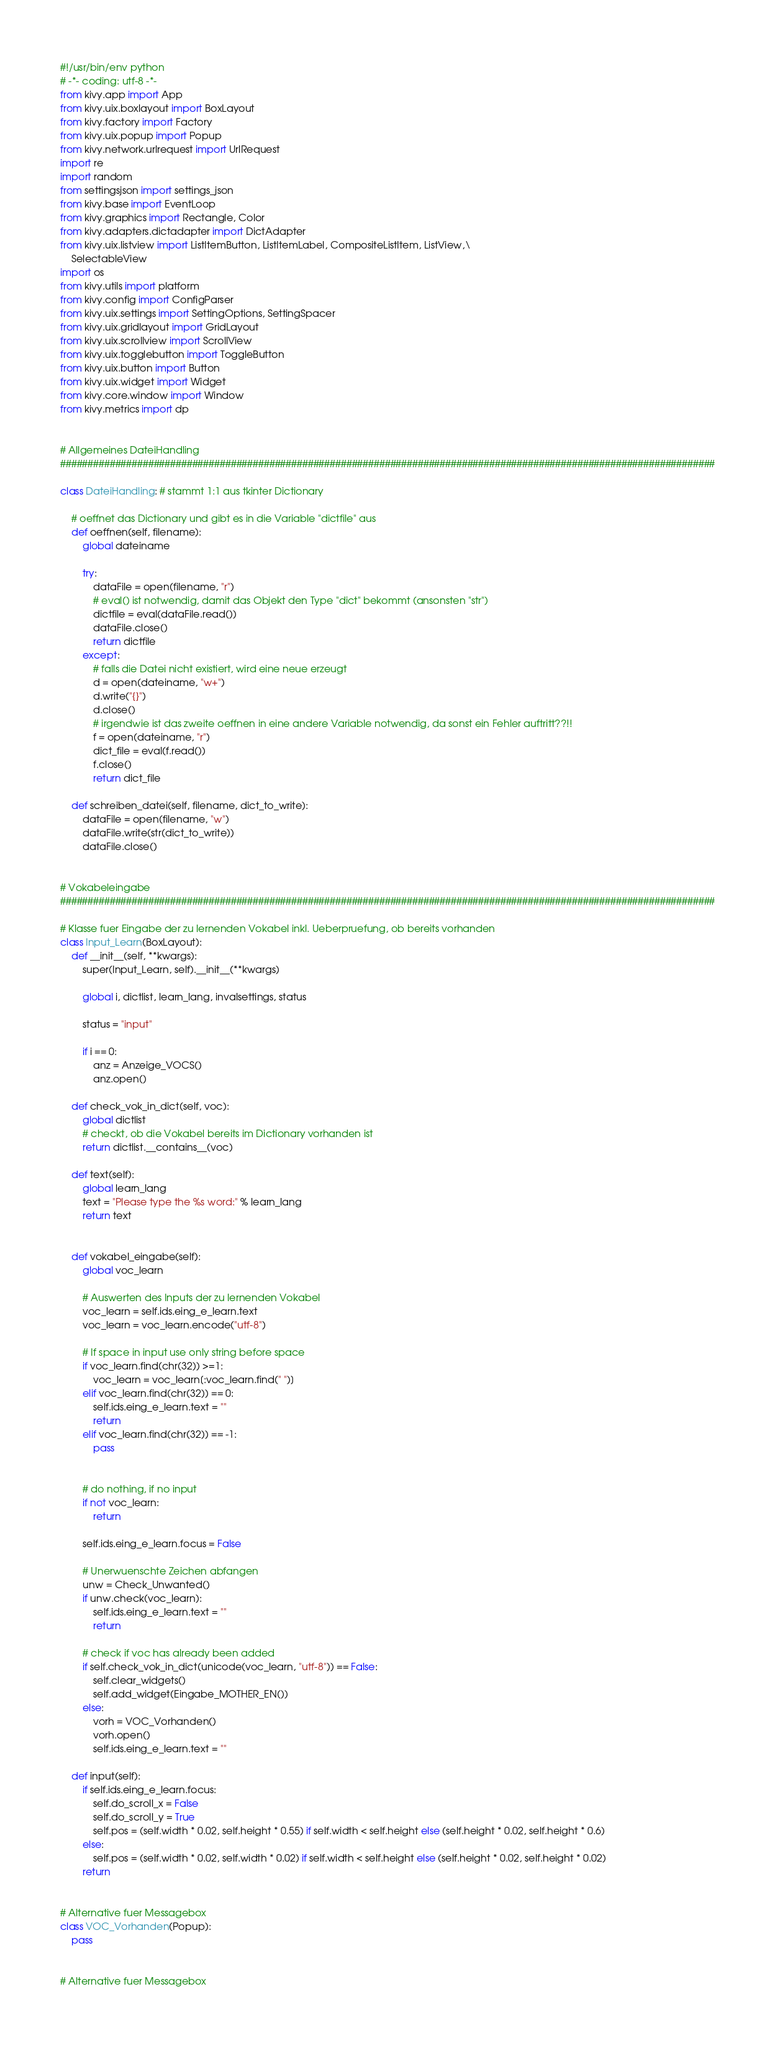Convert code to text. <code><loc_0><loc_0><loc_500><loc_500><_Python_>#!/usr/bin/env python
# -*- coding: utf-8 -*-
from kivy.app import App
from kivy.uix.boxlayout import BoxLayout
from kivy.factory import Factory
from kivy.uix.popup import Popup
from kivy.network.urlrequest import UrlRequest
import re
import random
from settingsjson import settings_json
from kivy.base import EventLoop
from kivy.graphics import Rectangle, Color
from kivy.adapters.dictadapter import DictAdapter
from kivy.uix.listview import ListItemButton, ListItemLabel, CompositeListItem, ListView,\
    SelectableView
import os
from kivy.utils import platform
from kivy.config import ConfigParser
from kivy.uix.settings import SettingOptions, SettingSpacer
from kivy.uix.gridlayout import GridLayout
from kivy.uix.scrollview import ScrollView
from kivy.uix.togglebutton import ToggleButton
from kivy.uix.button import Button
from kivy.uix.widget import Widget
from kivy.core.window import Window
from kivy.metrics import dp


# Allgemeines DateiHandling
#######################################################################################################################

class DateiHandling: # stammt 1:1 aus tkinter Dictionary
    
    # oeffnet das Dictionary und gibt es in die Variable "dictfile" aus
    def oeffnen(self, filename):
        global dateiname
        
        try:
            dataFile = open(filename, "r")
            # eval() ist notwendig, damit das Objekt den Type "dict" bekommt (ansonsten "str")
            dictfile = eval(dataFile.read())
            dataFile.close()
            return dictfile
        except:
            # falls die Datei nicht existiert, wird eine neue erzeugt
            d = open(dateiname, "w+")
            d.write("{}")
            d.close()
            # irgendwie ist das zweite oeffnen in eine andere Variable notwendig, da sonst ein Fehler auftritt??!!
            f = open(dateiname, "r")
            dict_file = eval(f.read())
            f.close()
            return dict_file
    
    def schreiben_datei(self, filename, dict_to_write):
        dataFile = open(filename, "w")
        dataFile.write(str(dict_to_write))
        dataFile.close()


# Vokabeleingabe
#######################################################################################################################

# Klasse fuer Eingabe der zu lernenden Vokabel inkl. Ueberpruefung, ob bereits vorhanden
class Input_Learn(BoxLayout):
    def __init__(self, **kwargs):
        super(Input_Learn, self).__init__(**kwargs)
        
        global i, dictlist, learn_lang, invalsettings, status
        
        status = "input"
        
        if i == 0:
            anz = Anzeige_VOCS()
            anz.open()
            
    def check_vok_in_dict(self, voc):
        global dictlist
        # checkt, ob die Vokabel bereits im Dictionary vorhanden ist
        return dictlist.__contains__(voc)
    
    def text(self):
        global learn_lang
        text = "Please type the %s word:" % learn_lang
        return text
        

    def vokabel_eingabe(self):
        global voc_learn
        
        # Auswerten des Inputs der zu lernenden Vokabel
        voc_learn = self.ids.eing_e_learn.text
        voc_learn = voc_learn.encode("utf-8")
        
        # If space in input use only string before space        
        if voc_learn.find(chr(32)) >=1:
            voc_learn = voc_learn[:voc_learn.find(" ")]
        elif voc_learn.find(chr(32)) == 0:
            self.ids.eing_e_learn.text = ""
            return
        elif voc_learn.find(chr(32)) == -1:
            pass
            
        
        # do nothing, if no input
        if not voc_learn:
            return
        
        self.ids.eing_e_learn.focus = False
        
        # Unerwuenschte Zeichen abfangen
        unw = Check_Unwanted()
        if unw.check(voc_learn):
            self.ids.eing_e_learn.text = ""
            return
        
        # check if voc has already been added
        if self.check_vok_in_dict(unicode(voc_learn, "utf-8")) == False:
            self.clear_widgets()
            self.add_widget(Eingabe_MOTHER_EN())
        else:
            vorh = VOC_Vorhanden()
            vorh.open()
            self.ids.eing_e_learn.text = ""
            
    def input(self):
        if self.ids.eing_e_learn.focus:
            self.do_scroll_x = False
            self.do_scroll_y = True
            self.pos = (self.width * 0.02, self.height * 0.55) if self.width < self.height else (self.height * 0.02, self.height * 0.6)
        else:
            self.pos = (self.width * 0.02, self.width * 0.02) if self.width < self.height else (self.height * 0.02, self.height * 0.02)
        return
            

# Alternative fuer Messagebox               
class VOC_Vorhanden(Popup):
    pass


# Alternative fuer Messagebox   </code> 